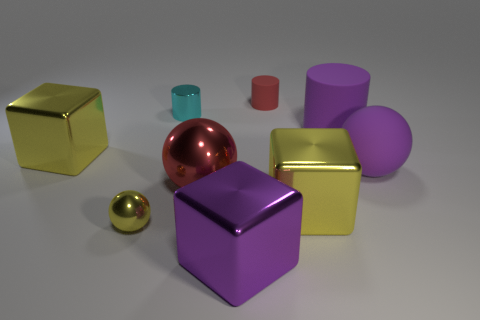Subtract all cylinders. How many objects are left? 6 Add 5 purple matte things. How many purple matte things are left? 7 Add 5 red matte spheres. How many red matte spheres exist? 5 Subtract 0 gray cubes. How many objects are left? 9 Subtract all big purple matte objects. Subtract all yellow balls. How many objects are left? 6 